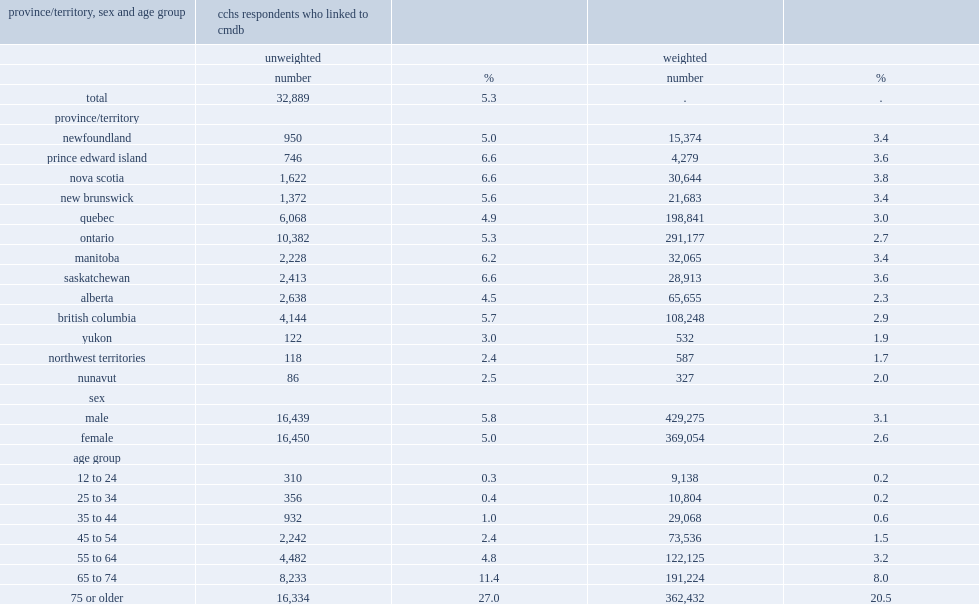Who had higher linkage rates (unweighted) to the cmdb, males or females? Male. Which age group had the highest linkage rates (unweighted) to the cmdb? 75 or older. 